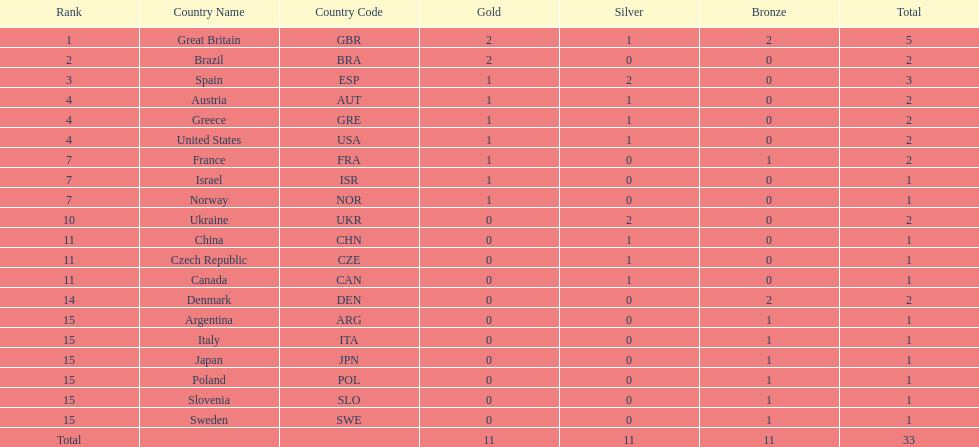What was the total number of medals won by united states? 2. 